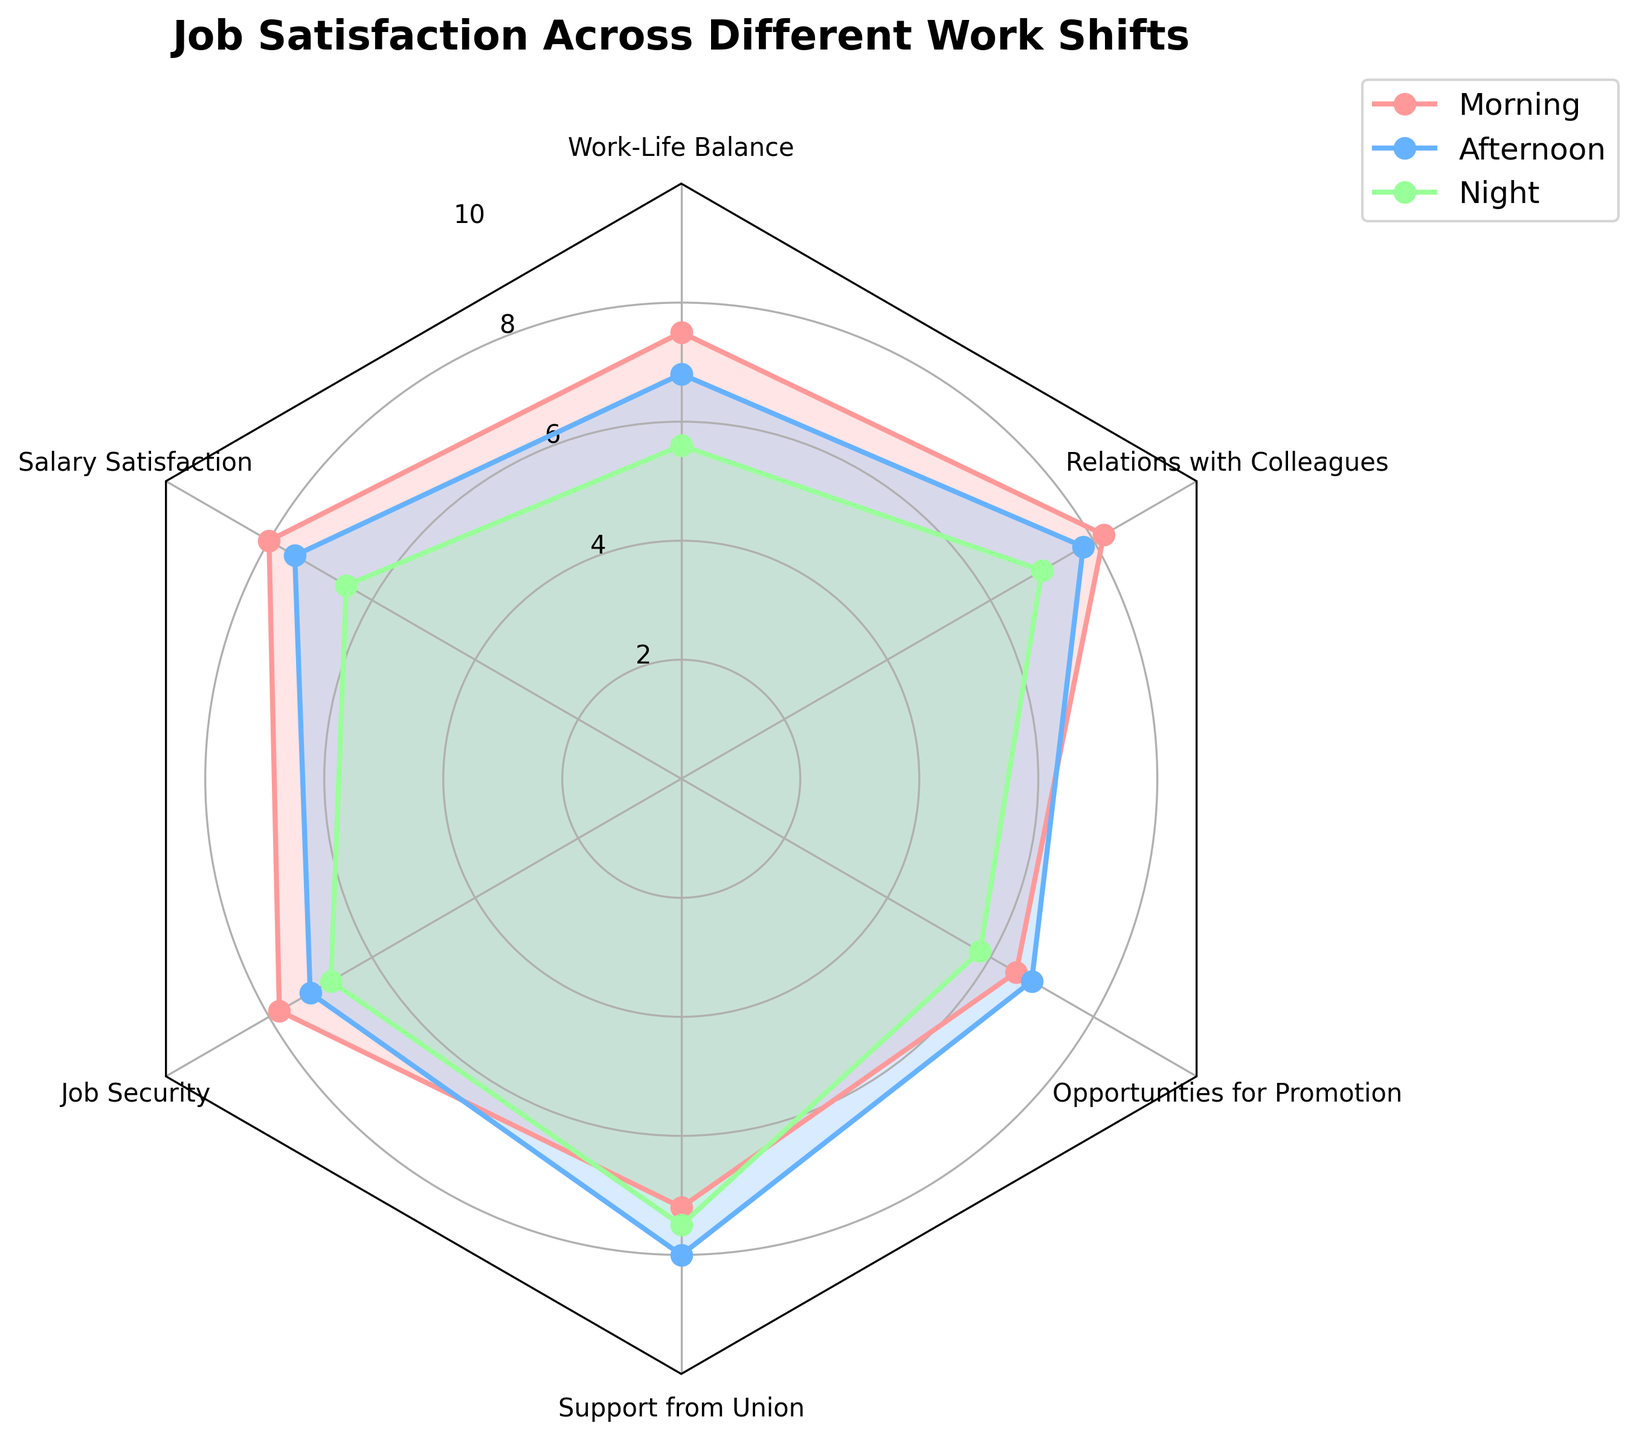What's the title of the radar chart? The title is usually displayed at the top of the radar chart and summarizes the main insight the chart presents.
Answer: Job Satisfaction Across Different Work Shifts How many categories of job satisfaction are shown in the figure? We count how many distinct categories radiate outwards from the center of the radar chart.
Answer: Six Which work shift has the highest satisfaction for "Relations with Colleagues"? Look at the "Relations with Colleagues" axis and identify the highest value among the three shifts (Morning, Afternoon, Night).
Answer: Morning For which category do the Morning and Afternoon shifts have equal satisfaction ratings? Compare the values for Morning and Afternoon shifts across all categories to find any match.
Answer: Opportunities for Promotion What is the average salary satisfaction across all work shifts? Sum the salary satisfaction values for Morning, Afternoon, and Night shifts, then divide the total by 3. (8.0 + 7.5 + 6.5) / 3 = 7.33
Answer: 7.33 How does the support from the union in the Night shift compare to the other two shifts? Compare the values for the "Support from Union" category for Morning, Afternoon, and Night shifts. Morning is 7.2, Afternoon is 8.0, and Night is 7.5, making Night fall between Morning and Afternoon.
Answer: Between Morning and Afternoon What is the largest difference in job satisfaction between any two shifts for any single category? Calculate the differences for each category between all pairs of shifts and identify the maximum difference. The highest difference is in "Work-Life Balance" between Morning (7.5) and Night (5.6). 7.5 - 5.6 = 1.9
Answer: 1.9 Which shift has the lowest job security rating? Locate the values for job security for Morning, Afternoon, and Night shifts and identify the lowest value.
Answer: Night In which category is the Afternoon shift's satisfaction higher than both the Morning and Night shifts? Compare all values for Afternoon with those of Morning and Night shifts across all categories. The "Support from Union" category has 8.0 (Afternoon) higher than 7.2 (Morning) and 7.5 (Night).
Answer: Support from Union 